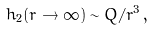<formula> <loc_0><loc_0><loc_500><loc_500>h _ { 2 } ( r \rightarrow \infty ) \sim Q / r ^ { 3 } \, ,</formula> 